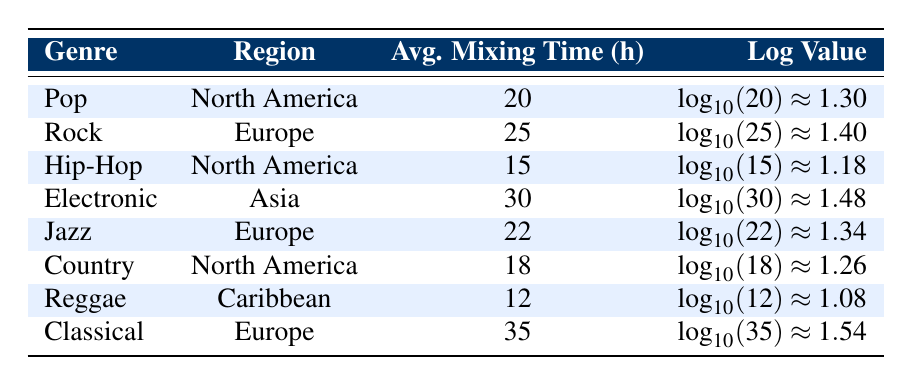What is the average mixing time for Pop music in North America? The table lists the average mixing time for Pop music in North America as 20 hours.
Answer: 20 Which genre has the longest average mixing time? In the table, Classical music has the highest average mixing time of 35 hours, which is greater than all other genres listed.
Answer: 35 How many genres have an average mixing time of 20 hours or more? The genres with 20 hours or more of average mixing time are Pop (20), Rock (25), Electronic (30), Jazz (22), and Classical (35). Counting these gives a total of 5 genres.
Answer: 5 Is the average mixing time for Reggae higher than that for Hip-Hop? The table shows that Reggae has an average mixing time of 12 hours while Hip-Hop has 15 hours. Since 12 is less than 15, the statement is false.
Answer: No What is the difference in average mixing time between Classical and Reggae? The average mixing time for Classical is 35 hours and for Reggae it is 12 hours. The difference is 35 - 12 = 23 hours.
Answer: 23 What is the average mixing time for all genres listed in Europe? The average mixing times for Europe are for Rock (25), Jazz (22), and Classical (35). Adding these gives 25 + 22 + 35 = 82, then dividing by 3 gives 82/3 = approximately 27.33 hours.
Answer: 27.33 Does Hip-Hop have the lowest average mixing time of all genres listed? According to the table, Reggae has an average mixing time of 12 hours, which is less than Hip-Hop's 15 hours. Therefore, this statement is false.
Answer: No How many genres in North America have an average mixing time below 20 hours? The genres in North America are Pop (20), Hip-Hop (15), and Country (18). Out of these, only Hip-Hop and Country have average mixing times below 20 hours. So there are 2 genres.
Answer: 2 What is the log value of the average mixing time for Electronic music? The average mixing time for Electronic music is 30 hours. The log value is calculated as log base 10 of 30, which is approximately 1.48 as stated in the table.
Answer: 1.48 